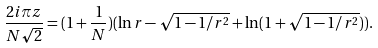Convert formula to latex. <formula><loc_0><loc_0><loc_500><loc_500>\frac { 2 i \pi z } { N \sqrt { 2 } } = ( 1 + \frac { 1 } { N } ) ( \ln r - \sqrt { 1 - 1 / r ^ { 2 } } + \ln ( 1 + \sqrt { 1 - 1 / r ^ { 2 } } ) ) .</formula> 